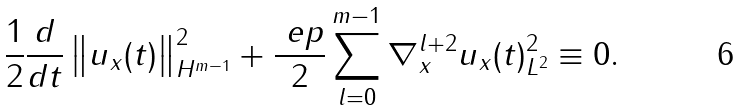Convert formula to latex. <formula><loc_0><loc_0><loc_500><loc_500>& \frac { 1 } { 2 } \frac { d } { d t } \left \| u _ { x } ( t ) \right \| _ { H ^ { m - 1 } } ^ { 2 } + \frac { \ e p } { 2 } \sum _ { l = 0 } ^ { m - 1 } \| \nabla _ { x } ^ { l + 2 } u _ { x } ( t ) \| _ { L ^ { 2 } } ^ { 2 } \equiv 0 .</formula> 